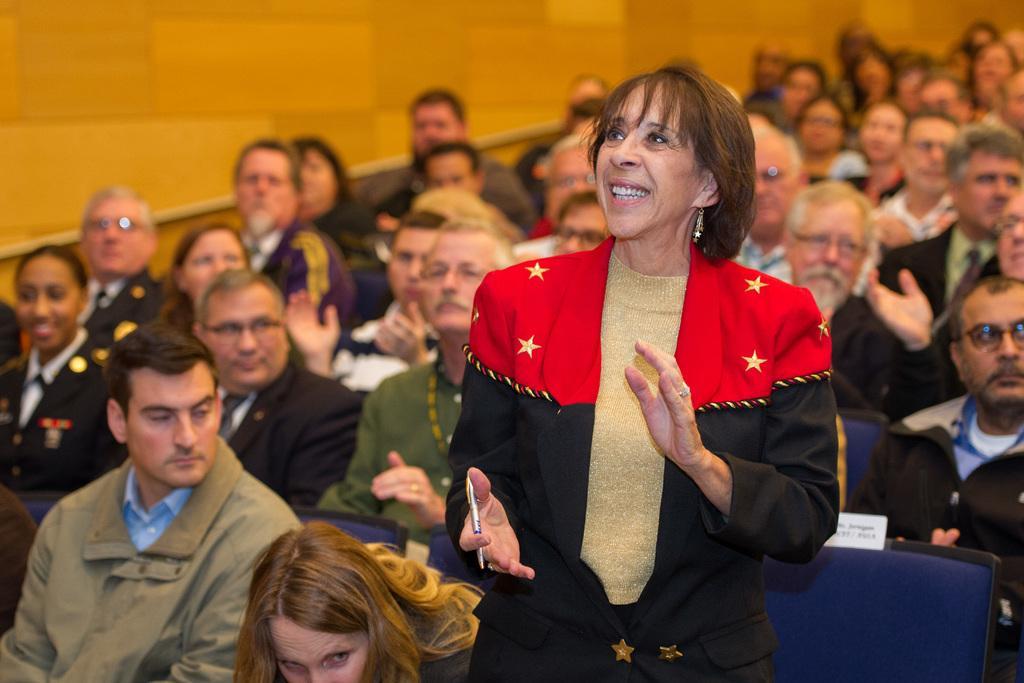Please provide a concise description of this image. In this image I can see people sitting on chairs among them a woman is standing and smiling. The woman is holding some object in the hand. Here I can see a wall. 